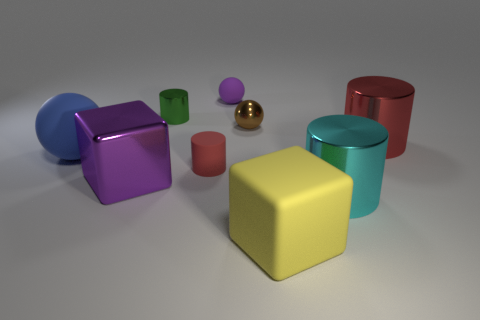Subtract all cyan cylinders. How many cylinders are left? 3 Add 1 small purple shiny objects. How many objects exist? 10 Subtract 1 purple spheres. How many objects are left? 8 Subtract all cubes. How many objects are left? 7 Subtract 2 balls. How many balls are left? 1 Subtract all cyan cylinders. Subtract all purple balls. How many cylinders are left? 3 Subtract all gray balls. How many cyan cylinders are left? 1 Subtract all tiny cyan metal balls. Subtract all small matte objects. How many objects are left? 7 Add 7 big red cylinders. How many big red cylinders are left? 8 Add 7 tiny rubber balls. How many tiny rubber balls exist? 8 